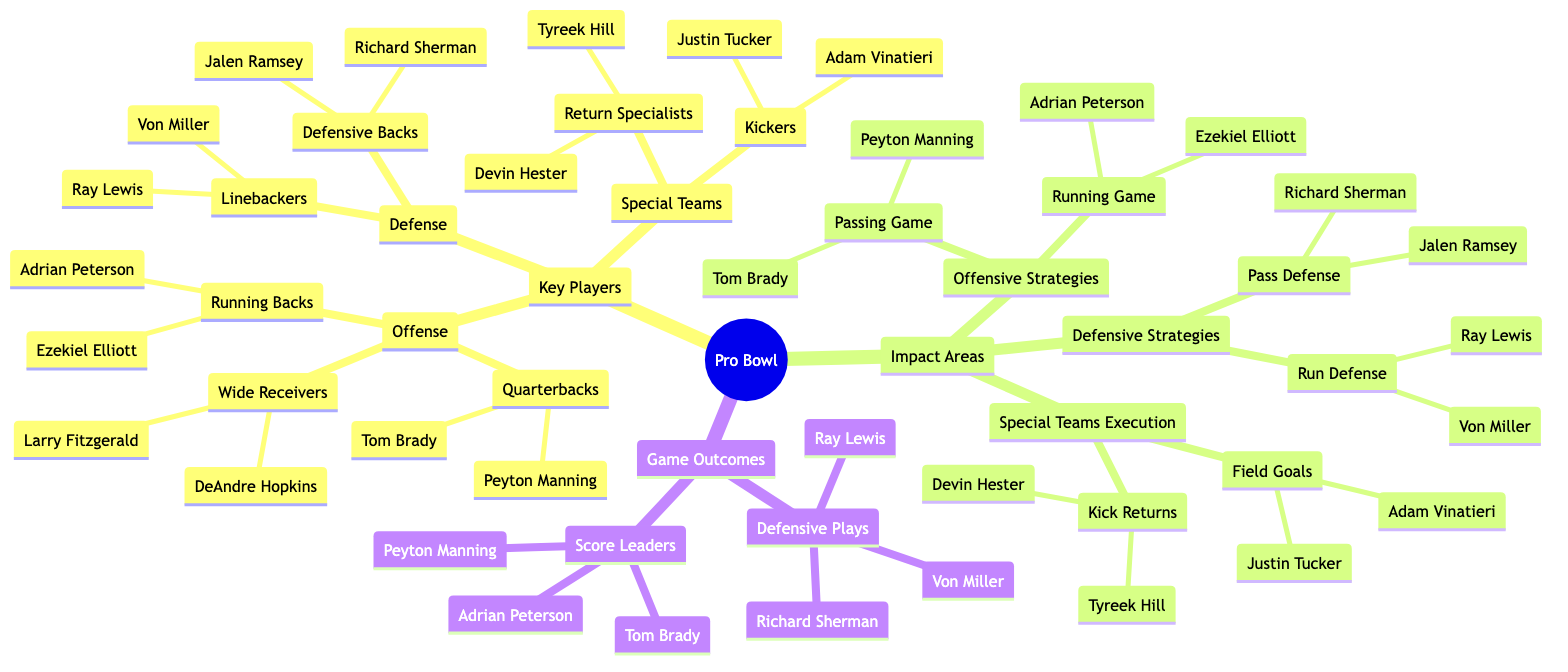What are the key positions in the Offense category? In the diagram, the Offense category includes three key positions: Quarterbacks, Running Backs, and Wide Receivers.
Answer: Quarterbacks, Running Backs, Wide Receivers How many kickers are listed in the Special Teams section? The Special Teams section has a subcategory for Kickers, which lists two players: Justin Tucker and Adam Vinatieri. Therefore, the total count is two.
Answer: 2 Who is noted for the Passing Game strategy? The Passing Game under Offensive Strategies specifically lists two players: Tom Brady and Peyton Manning, indicating their significance in this area.
Answer: Tom Brady, Peyton Manning Which players are identified as leading in Defensive Plays? The Game Outcomes section under Defensive Plays refers to three players: Ray Lewis, Richard Sherman, and Von Miller, highlighting their contributions.
Answer: Ray Lewis, Richard Sherman, Von Miller What is the relationship between Offensive Strategies and Score Leaders? Offensive Strategies details how the Passing and Running games are conducted while the Score Leaders lists Tom Brady, Peyton Manning, and Adrian Peterson, indicating their impact on scoring through their respective strategies.
Answer: Players influence scoring through strategies Who are the Running Backs mentioned in the Offense category? The Offense category includes a subcategory for Running Backs, which specifically lists Adrian Peterson and Ezekiel Elliott.
Answer: Adrian Peterson, Ezekiel Elliott Which players are associated with Field Goals execution? In the Special Teams Execution section, specifically under Field Goals, two kickers are identified: Justin Tucker and Adam Vinatieri.
Answer: Justin Tucker, Adam Vinatieri How many Defensive Backs are highlighted in the concept map? The Defense category includes a subcategory for Defensive Backs, which specifically lists two players: Richard Sherman and Jalen Ramsey, making the total count two.
Answer: 2 Which player appears in both the Passing Game and Score Leaders categories? Tom Brady appears in both the Passing Game strategy under Offensive Strategies and in the Score Leaders section, highlighting his dual role in the game.
Answer: Tom Brady 